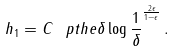<formula> <loc_0><loc_0><loc_500><loc_500>h _ { 1 } = C \ p t h { e \delta \log \frac { 1 } { \delta } } ^ { \frac { 2 \epsilon } { 1 - \epsilon } } \, .</formula> 